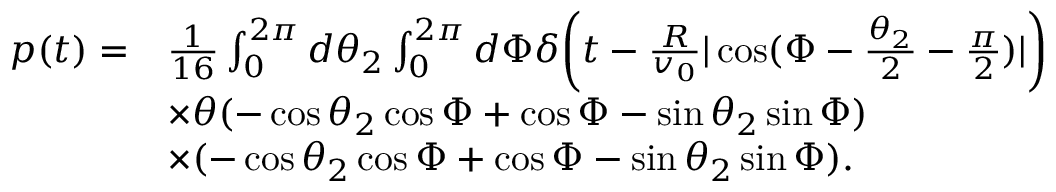Convert formula to latex. <formula><loc_0><loc_0><loc_500><loc_500>\begin{array} { r l } { p ( t ) = } & { \frac { 1 } { 1 6 } \int _ { 0 } ^ { 2 \pi } d \theta _ { 2 } \int _ { 0 } ^ { 2 \pi } d \Phi \delta \left ( t - \frac { R } { v _ { 0 } } | \cos ( \Phi - \frac { \theta _ { 2 } } { 2 } - \frac { \pi } { 2 } ) | \right ) } \\ & { \times \theta ( - \cos \theta _ { 2 } \cos \Phi + \cos \Phi - \sin \theta _ { 2 } \sin \Phi ) } \\ & { \times ( - \cos \theta _ { 2 } \cos \Phi + \cos \Phi - \sin \theta _ { 2 } \sin \Phi ) . } \end{array}</formula> 